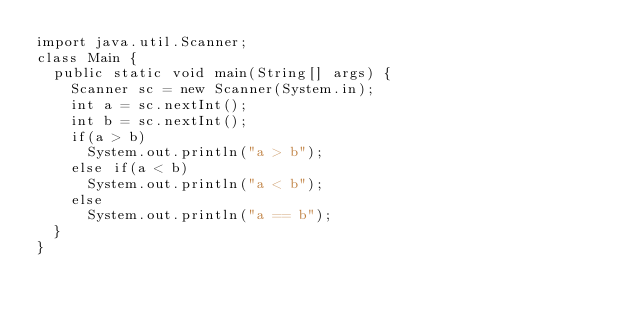Convert code to text. <code><loc_0><loc_0><loc_500><loc_500><_Java_>import java.util.Scanner;
class Main {
  public static void main(String[] args) {
    Scanner sc = new Scanner(System.in);
    int a = sc.nextInt();
    int b = sc.nextInt();
    if(a > b)
      System.out.println("a > b");
    else if(a < b)
      System.out.println("a < b");
    else
      System.out.println("a == b");
  }
}
</code> 